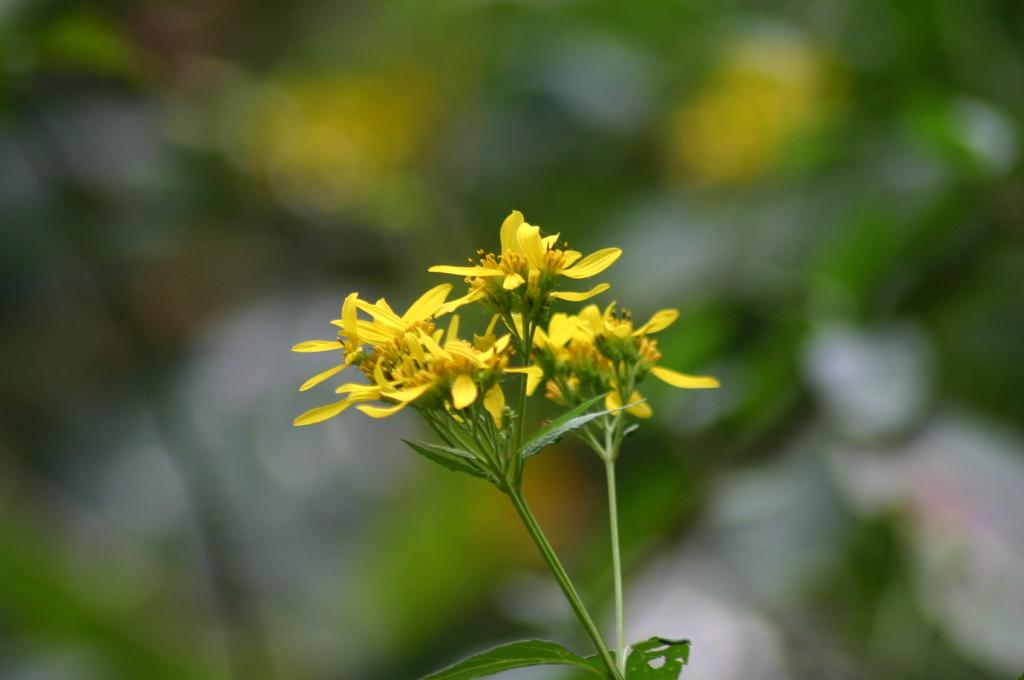What type of flowers are present in the image? The image contains yellow colored flowers. Can you describe the background of the image? The background of the image is blurred. What type of stitch is used to sew the tongue in the image? There is no mention of a tongue or stitching in the image, as it only contains yellow colored flowers and a blurred background. 